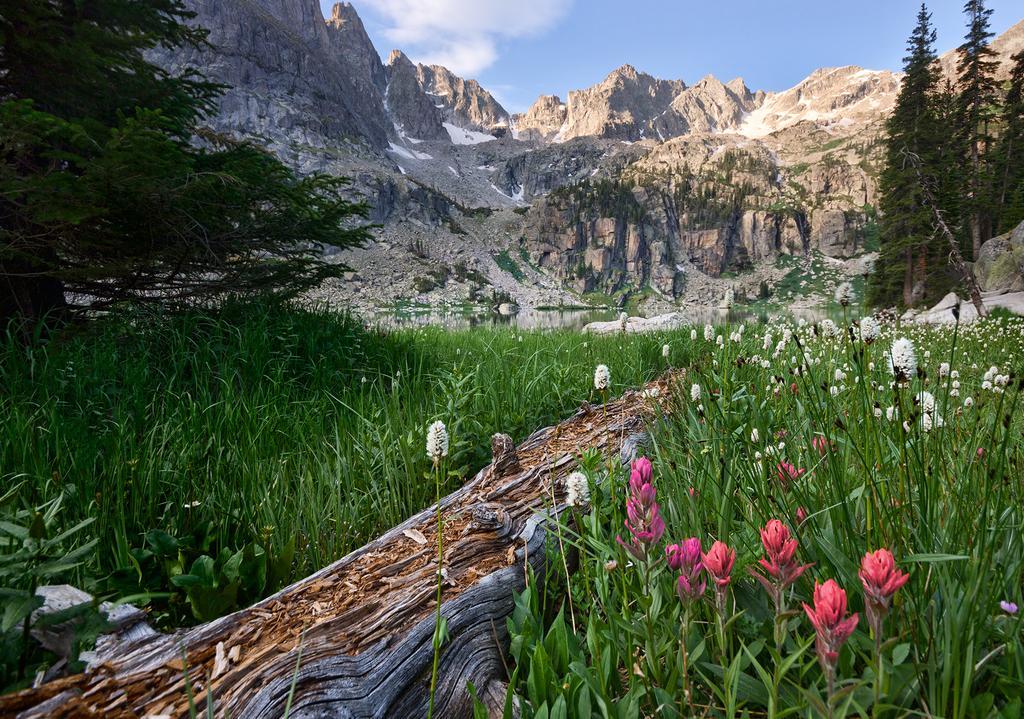Can you describe this image briefly? In this image we can see flowers plants, grass, trees and bark. Background of the image mountain and sky is there. 